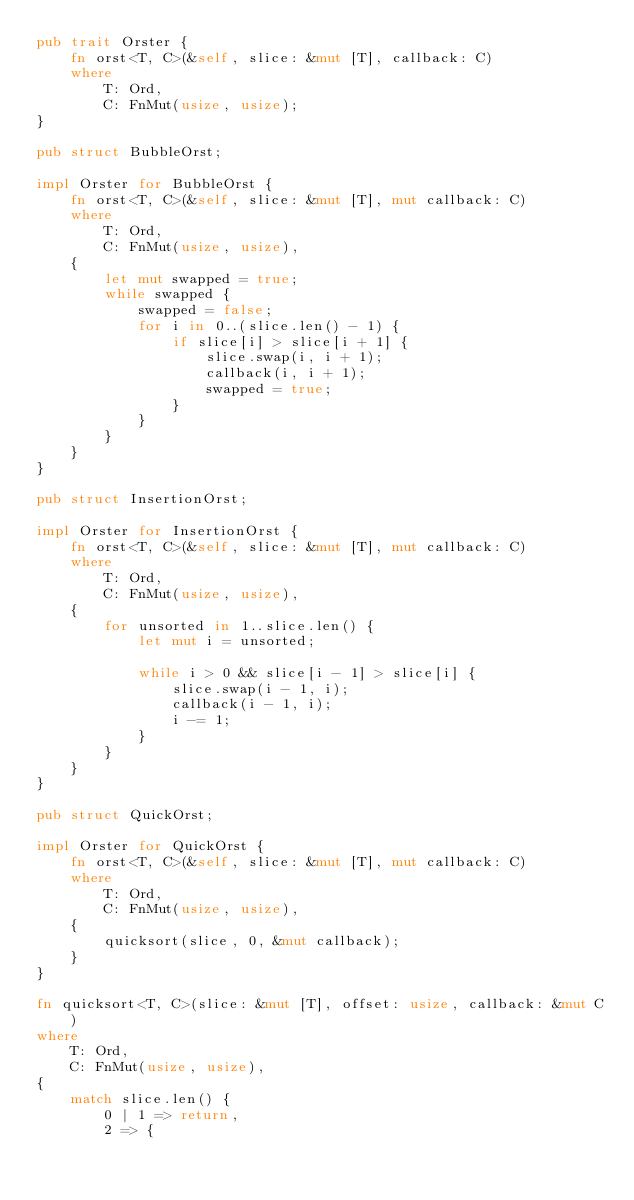Convert code to text. <code><loc_0><loc_0><loc_500><loc_500><_Rust_>pub trait Orster {
    fn orst<T, C>(&self, slice: &mut [T], callback: C)
    where
        T: Ord,
        C: FnMut(usize, usize);
}

pub struct BubbleOrst;

impl Orster for BubbleOrst {
    fn orst<T, C>(&self, slice: &mut [T], mut callback: C)
    where
        T: Ord,
        C: FnMut(usize, usize),
    {
        let mut swapped = true;
        while swapped {
            swapped = false;
            for i in 0..(slice.len() - 1) {
                if slice[i] > slice[i + 1] {
                    slice.swap(i, i + 1);
                    callback(i, i + 1);
                    swapped = true;
                }
            }
        }
    }
}

pub struct InsertionOrst;

impl Orster for InsertionOrst {
    fn orst<T, C>(&self, slice: &mut [T], mut callback: C)
    where
        T: Ord,
        C: FnMut(usize, usize),
    {
        for unsorted in 1..slice.len() {
            let mut i = unsorted;

            while i > 0 && slice[i - 1] > slice[i] {
                slice.swap(i - 1, i);
                callback(i - 1, i);
                i -= 1;
            }
        }
    }
}

pub struct QuickOrst;

impl Orster for QuickOrst {
    fn orst<T, C>(&self, slice: &mut [T], mut callback: C)
    where
        T: Ord,
        C: FnMut(usize, usize),
    {
        quicksort(slice, 0, &mut callback);
    }
}

fn quicksort<T, C>(slice: &mut [T], offset: usize, callback: &mut C)
where
    T: Ord,
    C: FnMut(usize, usize),
{
    match slice.len() {
        0 | 1 => return,
        2 => {</code> 